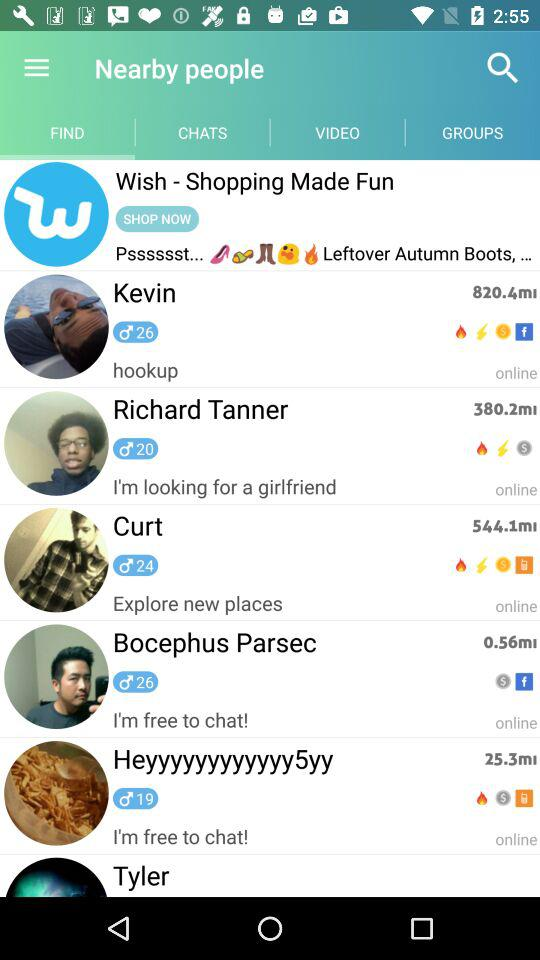Which option is selected? The selected option is "FIND". 